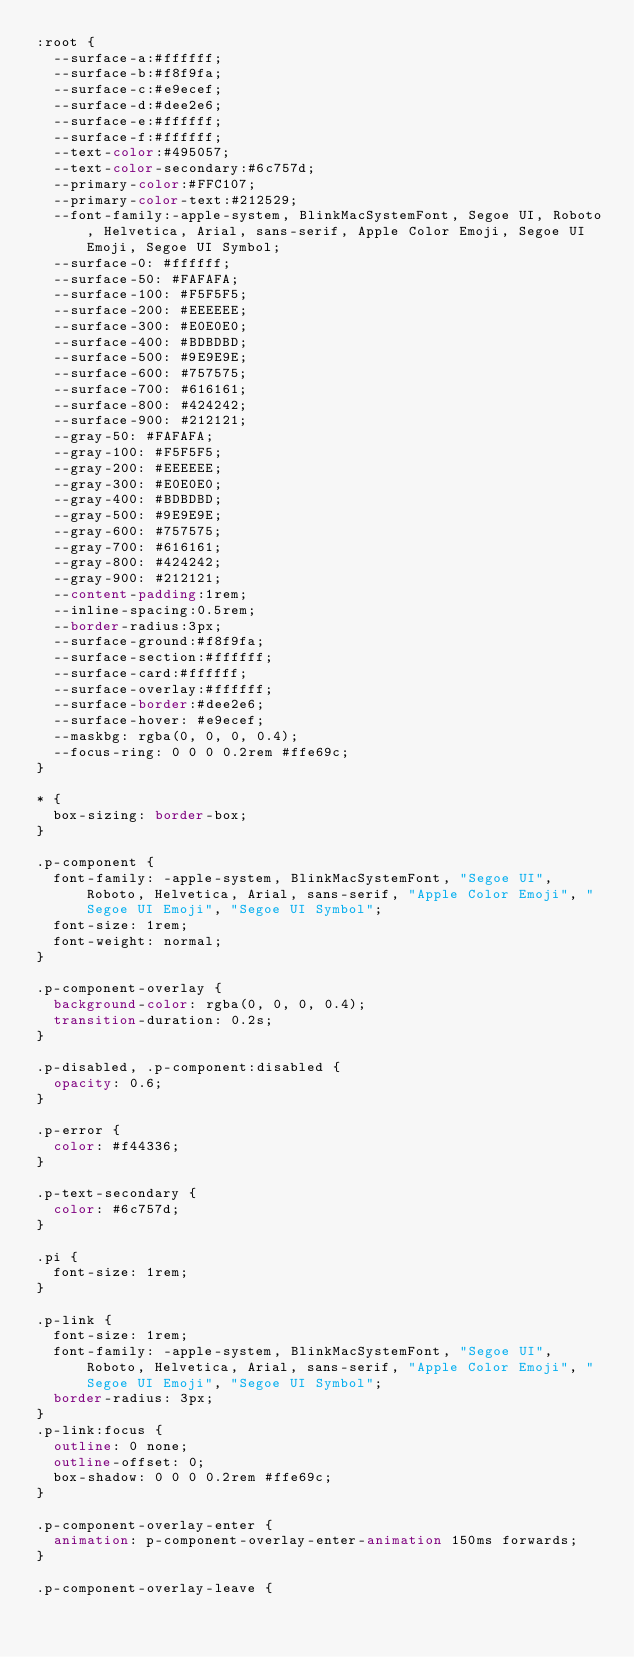<code> <loc_0><loc_0><loc_500><loc_500><_CSS_>:root {
  --surface-a:#ffffff;
  --surface-b:#f8f9fa;
  --surface-c:#e9ecef;
  --surface-d:#dee2e6;
  --surface-e:#ffffff;
  --surface-f:#ffffff;
  --text-color:#495057;
  --text-color-secondary:#6c757d;
  --primary-color:#FFC107;
  --primary-color-text:#212529;
  --font-family:-apple-system, BlinkMacSystemFont, Segoe UI, Roboto, Helvetica, Arial, sans-serif, Apple Color Emoji, Segoe UI Emoji, Segoe UI Symbol;
  --surface-0: #ffffff;
  --surface-50: #FAFAFA;
  --surface-100: #F5F5F5;
  --surface-200: #EEEEEE;
  --surface-300: #E0E0E0;
  --surface-400: #BDBDBD;
  --surface-500: #9E9E9E;
  --surface-600: #757575;
  --surface-700: #616161;
  --surface-800: #424242;
  --surface-900: #212121;
  --gray-50: #FAFAFA;
  --gray-100: #F5F5F5;
  --gray-200: #EEEEEE;
  --gray-300: #E0E0E0;
  --gray-400: #BDBDBD;
  --gray-500: #9E9E9E;
  --gray-600: #757575;
  --gray-700: #616161;
  --gray-800: #424242;
  --gray-900: #212121;
  --content-padding:1rem;
  --inline-spacing:0.5rem;
  --border-radius:3px;
  --surface-ground:#f8f9fa;
  --surface-section:#ffffff;
  --surface-card:#ffffff;
  --surface-overlay:#ffffff;
  --surface-border:#dee2e6;
  --surface-hover: #e9ecef;
  --maskbg: rgba(0, 0, 0, 0.4);
  --focus-ring: 0 0 0 0.2rem #ffe69c;
}

* {
  box-sizing: border-box;
}

.p-component {
  font-family: -apple-system, BlinkMacSystemFont, "Segoe UI", Roboto, Helvetica, Arial, sans-serif, "Apple Color Emoji", "Segoe UI Emoji", "Segoe UI Symbol";
  font-size: 1rem;
  font-weight: normal;
}

.p-component-overlay {
  background-color: rgba(0, 0, 0, 0.4);
  transition-duration: 0.2s;
}

.p-disabled, .p-component:disabled {
  opacity: 0.6;
}

.p-error {
  color: #f44336;
}

.p-text-secondary {
  color: #6c757d;
}

.pi {
  font-size: 1rem;
}

.p-link {
  font-size: 1rem;
  font-family: -apple-system, BlinkMacSystemFont, "Segoe UI", Roboto, Helvetica, Arial, sans-serif, "Apple Color Emoji", "Segoe UI Emoji", "Segoe UI Symbol";
  border-radius: 3px;
}
.p-link:focus {
  outline: 0 none;
  outline-offset: 0;
  box-shadow: 0 0 0 0.2rem #ffe69c;
}

.p-component-overlay-enter {
  animation: p-component-overlay-enter-animation 150ms forwards;
}

.p-component-overlay-leave {</code> 